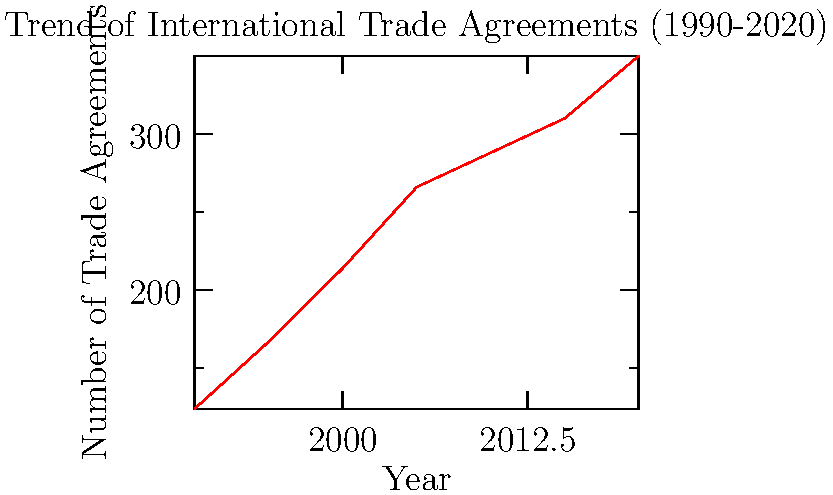Based on the line graph depicting the trend of international trade agreements from 1990 to 2020, what can be inferred about the rate of growth in these agreements during the period shown? How might this trend relate to global economic integration and the changing landscape of international relations? To answer this question, we need to analyze the graph and interpret its implications:

1. Overall trend: The graph shows a clear upward trend in the number of international trade agreements from 1990 to 2020.

2. Rate of growth:
   a) 1990-2000: Steep increase, from about 124 to 214 agreements.
   b) 2000-2010: Continued growth, but at a slightly slower rate, reaching about 288 agreements.
   c) 2010-2020: Growth continues, reaching approximately 350 agreements by 2020.

3. Implications for global economic integration:
   a) The increasing number of trade agreements suggests a trend towards greater economic interconnectedness among nations.
   b) This could indicate a shift towards more open markets and reduced trade barriers globally.

4. Changing landscape of international relations:
   a) The trend may reflect a move towards multilateralism and regional economic blocs.
   b) It could also signify changing power dynamics, with nations seeking to strengthen economic ties as a form of soft power.

5. Journalist's perspective:
   As a former journalist transitioning to international relations, this trend highlights the growing importance of understanding complex economic relationships between nations and their impact on global politics.

The rate of growth in international trade agreements has been consistently positive but slowing over time, indicating a sustained push towards global economic integration and evolving international relations dynamics.
Answer: Positive but decelerating growth in trade agreements, reflecting increased global economic integration and evolving international relations. 